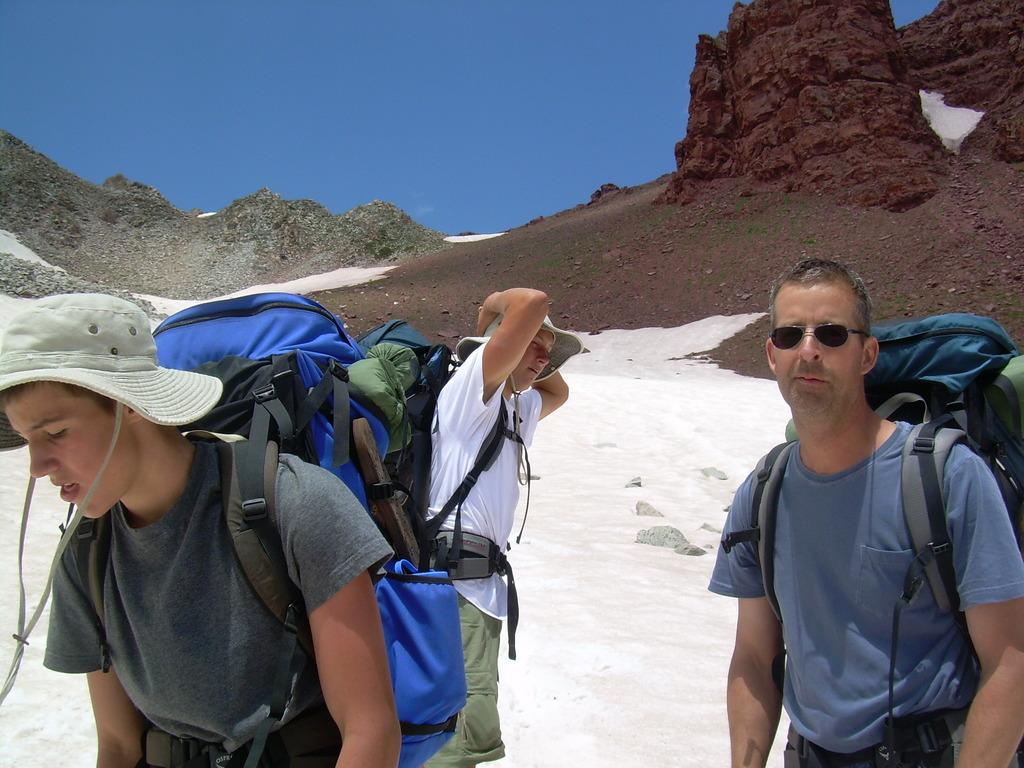How many persons are in the group in the image? There is a group of persons in the image. What are the persons wearing on their backs? The persons are wearing backpacks. What type of headwear are the persons wearing? The persons are wearing hats. What type of eyewear are the persons wearing? The persons are wearing spectacles. What is the terrain like in the image? The group is standing in the snow, and there are hills visible in the background. What is visible in the sky in the image? The sky is visible in the background of the image. What type of riddle can be solved by the group in the image? There is no riddle present in the image, and therefore no such activity can be observed. How does the hose affect the group's experience in the image? There is no hose present in the image, so it cannot affect the group's experience. 